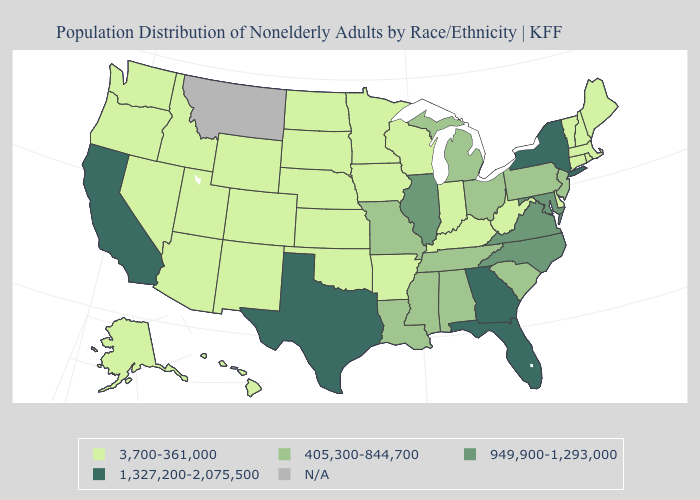Which states hav the highest value in the MidWest?
Write a very short answer. Illinois. Does Indiana have the highest value in the MidWest?
Concise answer only. No. Name the states that have a value in the range N/A?
Be succinct. Montana. Does New Mexico have the highest value in the West?
Be succinct. No. What is the value of Montana?
Give a very brief answer. N/A. What is the lowest value in the Northeast?
Be succinct. 3,700-361,000. What is the lowest value in states that border California?
Write a very short answer. 3,700-361,000. Name the states that have a value in the range N/A?
Be succinct. Montana. Does Texas have the highest value in the South?
Answer briefly. Yes. What is the highest value in the USA?
Quick response, please. 1,327,200-2,075,500. What is the highest value in states that border Wyoming?
Answer briefly. 3,700-361,000. What is the lowest value in the USA?
Give a very brief answer. 3,700-361,000. What is the value of South Dakota?
Give a very brief answer. 3,700-361,000. 